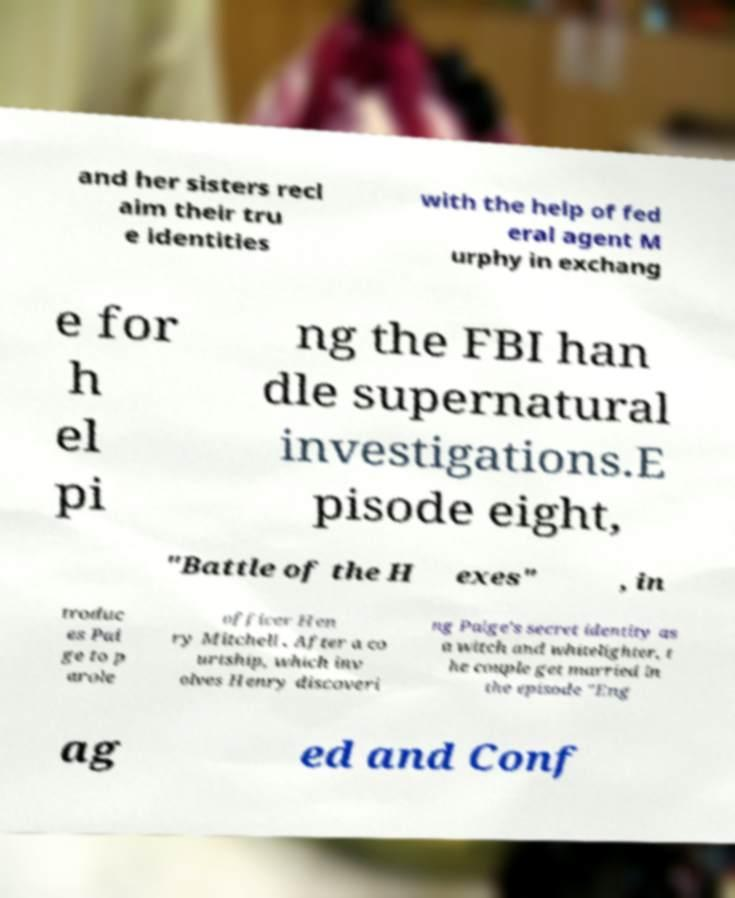What messages or text are displayed in this image? I need them in a readable, typed format. and her sisters recl aim their tru e identities with the help of fed eral agent M urphy in exchang e for h el pi ng the FBI han dle supernatural investigations.E pisode eight, "Battle of the H exes" , in troduc es Pai ge to p arole officer Hen ry Mitchell . After a co urtship, which inv olves Henry discoveri ng Paige's secret identity as a witch and whitelighter, t he couple get married in the episode "Eng ag ed and Conf 